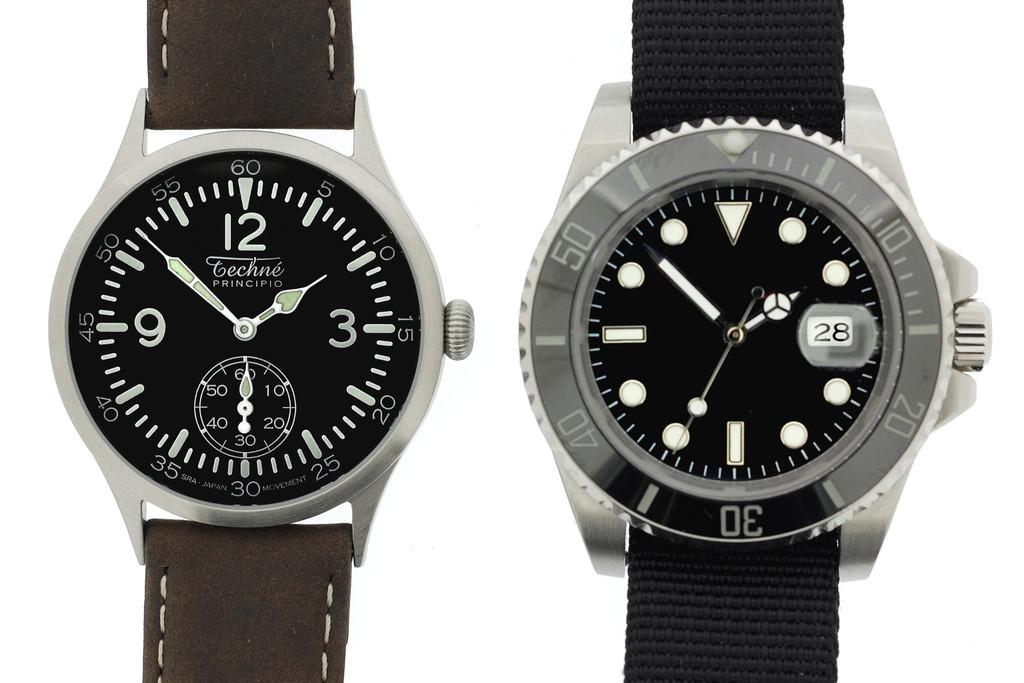<image>
Relay a brief, clear account of the picture shown. two watches, one says Techne PRINCIPIO. 